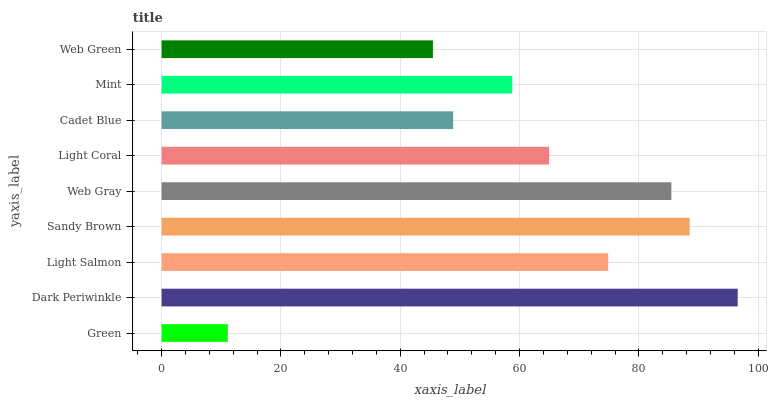Is Green the minimum?
Answer yes or no. Yes. Is Dark Periwinkle the maximum?
Answer yes or no. Yes. Is Light Salmon the minimum?
Answer yes or no. No. Is Light Salmon the maximum?
Answer yes or no. No. Is Dark Periwinkle greater than Light Salmon?
Answer yes or no. Yes. Is Light Salmon less than Dark Periwinkle?
Answer yes or no. Yes. Is Light Salmon greater than Dark Periwinkle?
Answer yes or no. No. Is Dark Periwinkle less than Light Salmon?
Answer yes or no. No. Is Light Coral the high median?
Answer yes or no. Yes. Is Light Coral the low median?
Answer yes or no. Yes. Is Dark Periwinkle the high median?
Answer yes or no. No. Is Dark Periwinkle the low median?
Answer yes or no. No. 